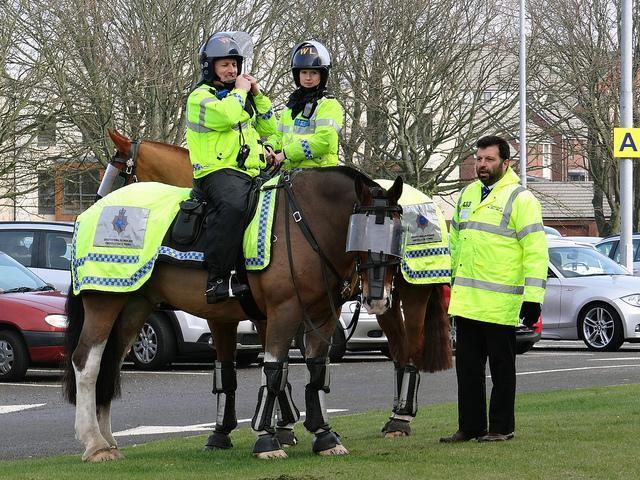How many people are in the picture?
Give a very brief answer. 3. How many cars are in the picture?
Give a very brief answer. 4. How many horses are in the photo?
Give a very brief answer. 2. 